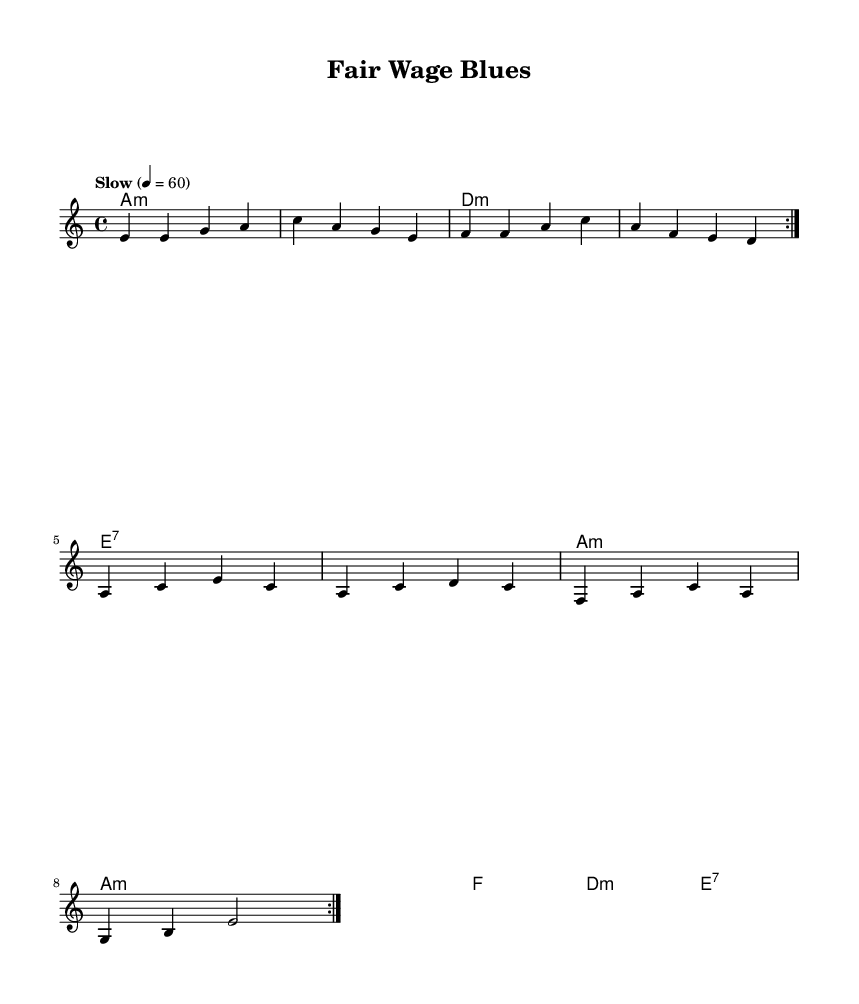What is the key signature of this music? The key signature is A minor, which contains no sharps or flats. It is indicated at the beginning of the staff.
Answer: A minor What is the time signature of this music? The time signature is 4/4, which means there are four beats per measure and a quarter note gets one beat. This is located at the beginning of the staff.
Answer: 4/4 What is the tempo indication for this piece? The tempo is marked as "Slow" with a metronome marking of 60 beats per minute. This is typically denoted at the start of the score before the melody begins.
Answer: Slow 4 = 60 How many times is the melody repeated in the piece? The melody is repeated two times, as indicated by the repeat sign "volta 2" at the beginning of the melody section.
Answer: 2 What are the two main themes in the lyrics? The two main themes in the lyrics are "Fair wages" and "Workers' rights", which are emphasized in both the verse and the chorus. The lyrics consistently speak to these themes throughout.
Answer: Fair wages and Workers' rights What type of harmony is primarily used in this piece? The harmony is primarily comprised of minor chords, specifically A minor and D minor, which are common in Blues music and contribute to the overall melancholic feel of the song.
Answer: Minor chords What message is conveyed through the chorus? The chorus conveys a clear message advocating for "fair pay" and "respect" for workers' rights, indicating a call for social justice and equality. This is central to the song's theme and purpose.
Answer: Fair pay and respect 